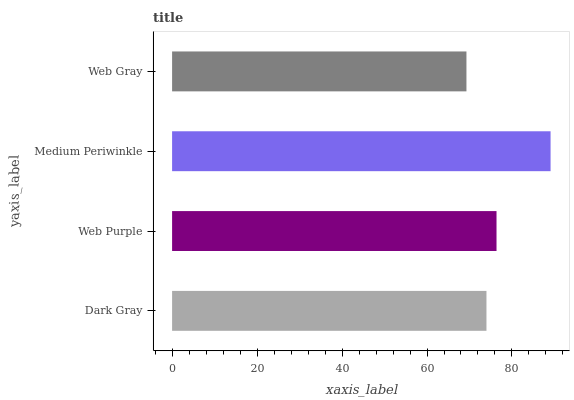Is Web Gray the minimum?
Answer yes or no. Yes. Is Medium Periwinkle the maximum?
Answer yes or no. Yes. Is Web Purple the minimum?
Answer yes or no. No. Is Web Purple the maximum?
Answer yes or no. No. Is Web Purple greater than Dark Gray?
Answer yes or no. Yes. Is Dark Gray less than Web Purple?
Answer yes or no. Yes. Is Dark Gray greater than Web Purple?
Answer yes or no. No. Is Web Purple less than Dark Gray?
Answer yes or no. No. Is Web Purple the high median?
Answer yes or no. Yes. Is Dark Gray the low median?
Answer yes or no. Yes. Is Medium Periwinkle the high median?
Answer yes or no. No. Is Web Purple the low median?
Answer yes or no. No. 